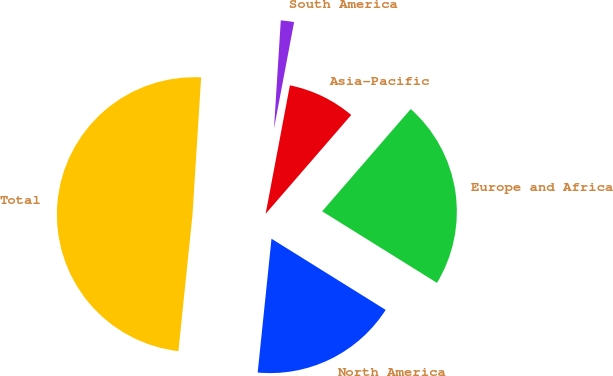Convert chart to OTSL. <chart><loc_0><loc_0><loc_500><loc_500><pie_chart><fcel>North America<fcel>Europe and Africa<fcel>Asia-Pacific<fcel>South America<fcel>Total<nl><fcel>17.77%<fcel>22.51%<fcel>8.39%<fcel>1.97%<fcel>49.36%<nl></chart> 